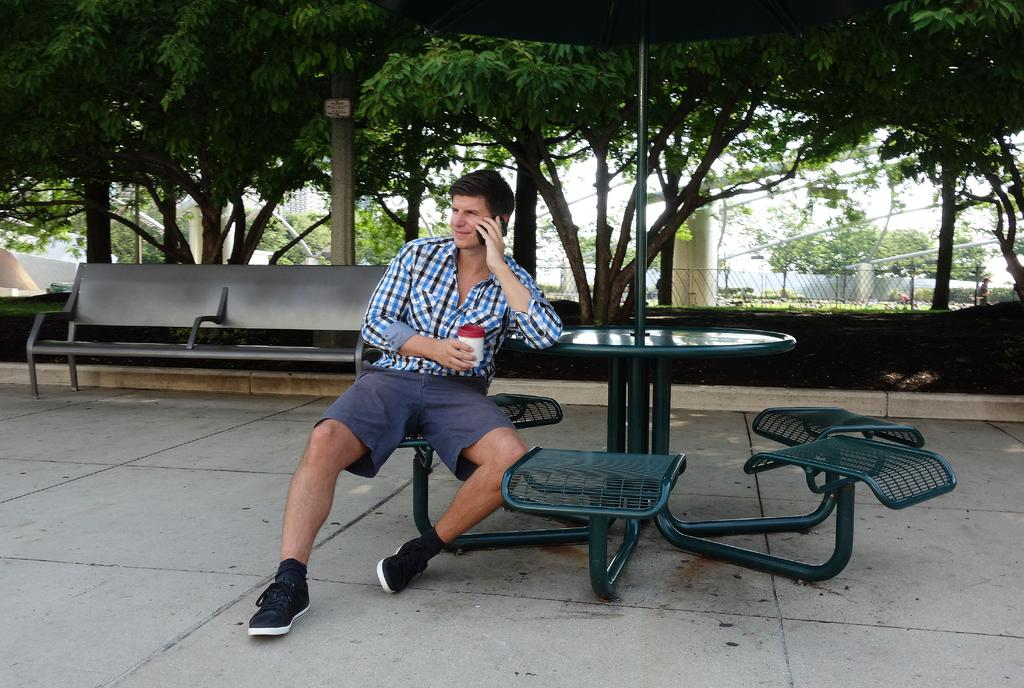What is the main subject of the image? There is a person sitting on a chair in the image. Where is the person located in the image? The person is at the center of the image. What is behind the person in the image? There is a bench behind the person. What can be seen in the background of the image? There are trees in the background of the image. What type of tax is being discussed by the person in the image? There is no indication in the image that the person is discussing any type of tax. 